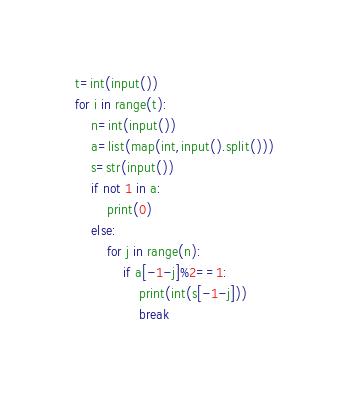Convert code to text. <code><loc_0><loc_0><loc_500><loc_500><_Python_>t=int(input())
for i in range(t):
    n=int(input())
    a=list(map(int,input().split()))
    s=str(input())
    if not 1 in a:
        print(0)
    else:
        for j in range(n):
            if a[-1-j]%2==1:
                print(int(s[-1-j]))
                break</code> 